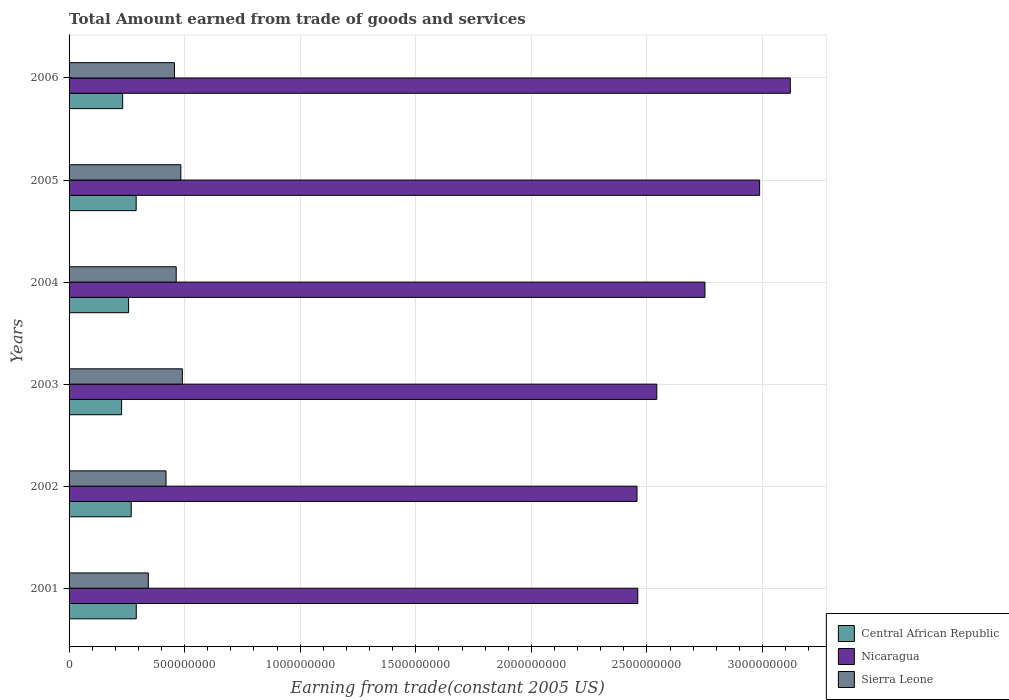Are the number of bars per tick equal to the number of legend labels?
Your response must be concise. Yes. Are the number of bars on each tick of the Y-axis equal?
Your answer should be very brief. Yes. How many bars are there on the 3rd tick from the bottom?
Offer a very short reply. 3. What is the label of the 1st group of bars from the top?
Your response must be concise. 2006. In how many cases, is the number of bars for a given year not equal to the number of legend labels?
Offer a terse response. 0. What is the total amount earned by trading goods and services in Nicaragua in 2003?
Ensure brevity in your answer.  2.54e+09. Across all years, what is the maximum total amount earned by trading goods and services in Nicaragua?
Keep it short and to the point. 3.12e+09. Across all years, what is the minimum total amount earned by trading goods and services in Sierra Leone?
Provide a succinct answer. 3.43e+08. What is the total total amount earned by trading goods and services in Central African Republic in the graph?
Offer a terse response. 1.57e+09. What is the difference between the total amount earned by trading goods and services in Central African Republic in 2001 and that in 2002?
Provide a succinct answer. 2.18e+07. What is the difference between the total amount earned by trading goods and services in Nicaragua in 2004 and the total amount earned by trading goods and services in Central African Republic in 2001?
Your response must be concise. 2.46e+09. What is the average total amount earned by trading goods and services in Central African Republic per year?
Your answer should be very brief. 2.61e+08. In the year 2006, what is the difference between the total amount earned by trading goods and services in Central African Republic and total amount earned by trading goods and services in Nicaragua?
Ensure brevity in your answer.  -2.89e+09. What is the ratio of the total amount earned by trading goods and services in Nicaragua in 2002 to that in 2003?
Offer a terse response. 0.97. Is the total amount earned by trading goods and services in Central African Republic in 2001 less than that in 2005?
Make the answer very short. No. What is the difference between the highest and the second highest total amount earned by trading goods and services in Nicaragua?
Offer a very short reply. 1.33e+08. What is the difference between the highest and the lowest total amount earned by trading goods and services in Sierra Leone?
Keep it short and to the point. 1.47e+08. Is the sum of the total amount earned by trading goods and services in Nicaragua in 2003 and 2004 greater than the maximum total amount earned by trading goods and services in Sierra Leone across all years?
Provide a succinct answer. Yes. What does the 1st bar from the top in 2003 represents?
Give a very brief answer. Sierra Leone. What does the 2nd bar from the bottom in 2005 represents?
Give a very brief answer. Nicaragua. Is it the case that in every year, the sum of the total amount earned by trading goods and services in Central African Republic and total amount earned by trading goods and services in Nicaragua is greater than the total amount earned by trading goods and services in Sierra Leone?
Ensure brevity in your answer.  Yes. How many bars are there?
Give a very brief answer. 18. Are all the bars in the graph horizontal?
Your answer should be very brief. Yes. Does the graph contain any zero values?
Your answer should be very brief. No. How many legend labels are there?
Provide a succinct answer. 3. How are the legend labels stacked?
Keep it short and to the point. Vertical. What is the title of the graph?
Provide a short and direct response. Total Amount earned from trade of goods and services. Does "Sub-Saharan Africa (developing only)" appear as one of the legend labels in the graph?
Offer a terse response. No. What is the label or title of the X-axis?
Give a very brief answer. Earning from trade(constant 2005 US). What is the label or title of the Y-axis?
Give a very brief answer. Years. What is the Earning from trade(constant 2005 US) in Central African Republic in 2001?
Keep it short and to the point. 2.91e+08. What is the Earning from trade(constant 2005 US) of Nicaragua in 2001?
Provide a succinct answer. 2.46e+09. What is the Earning from trade(constant 2005 US) of Sierra Leone in 2001?
Your answer should be very brief. 3.43e+08. What is the Earning from trade(constant 2005 US) in Central African Republic in 2002?
Provide a short and direct response. 2.69e+08. What is the Earning from trade(constant 2005 US) of Nicaragua in 2002?
Offer a terse response. 2.46e+09. What is the Earning from trade(constant 2005 US) in Sierra Leone in 2002?
Make the answer very short. 4.19e+08. What is the Earning from trade(constant 2005 US) in Central African Republic in 2003?
Provide a short and direct response. 2.27e+08. What is the Earning from trade(constant 2005 US) in Nicaragua in 2003?
Your answer should be compact. 2.54e+09. What is the Earning from trade(constant 2005 US) in Sierra Leone in 2003?
Ensure brevity in your answer.  4.90e+08. What is the Earning from trade(constant 2005 US) in Central African Republic in 2004?
Provide a short and direct response. 2.58e+08. What is the Earning from trade(constant 2005 US) in Nicaragua in 2004?
Offer a very short reply. 2.75e+09. What is the Earning from trade(constant 2005 US) in Sierra Leone in 2004?
Give a very brief answer. 4.63e+08. What is the Earning from trade(constant 2005 US) in Central African Republic in 2005?
Provide a succinct answer. 2.90e+08. What is the Earning from trade(constant 2005 US) in Nicaragua in 2005?
Provide a short and direct response. 2.99e+09. What is the Earning from trade(constant 2005 US) in Sierra Leone in 2005?
Your response must be concise. 4.84e+08. What is the Earning from trade(constant 2005 US) of Central African Republic in 2006?
Ensure brevity in your answer.  2.32e+08. What is the Earning from trade(constant 2005 US) of Nicaragua in 2006?
Keep it short and to the point. 3.12e+09. What is the Earning from trade(constant 2005 US) of Sierra Leone in 2006?
Your response must be concise. 4.56e+08. Across all years, what is the maximum Earning from trade(constant 2005 US) of Central African Republic?
Offer a very short reply. 2.91e+08. Across all years, what is the maximum Earning from trade(constant 2005 US) in Nicaragua?
Ensure brevity in your answer.  3.12e+09. Across all years, what is the maximum Earning from trade(constant 2005 US) in Sierra Leone?
Give a very brief answer. 4.90e+08. Across all years, what is the minimum Earning from trade(constant 2005 US) in Central African Republic?
Your answer should be very brief. 2.27e+08. Across all years, what is the minimum Earning from trade(constant 2005 US) of Nicaragua?
Offer a very short reply. 2.46e+09. Across all years, what is the minimum Earning from trade(constant 2005 US) of Sierra Leone?
Offer a very short reply. 3.43e+08. What is the total Earning from trade(constant 2005 US) of Central African Republic in the graph?
Make the answer very short. 1.57e+09. What is the total Earning from trade(constant 2005 US) in Nicaragua in the graph?
Your answer should be very brief. 1.63e+1. What is the total Earning from trade(constant 2005 US) of Sierra Leone in the graph?
Ensure brevity in your answer.  2.66e+09. What is the difference between the Earning from trade(constant 2005 US) of Central African Republic in 2001 and that in 2002?
Offer a very short reply. 2.18e+07. What is the difference between the Earning from trade(constant 2005 US) in Nicaragua in 2001 and that in 2002?
Your answer should be very brief. 3.38e+06. What is the difference between the Earning from trade(constant 2005 US) of Sierra Leone in 2001 and that in 2002?
Offer a very short reply. -7.66e+07. What is the difference between the Earning from trade(constant 2005 US) of Central African Republic in 2001 and that in 2003?
Provide a short and direct response. 6.35e+07. What is the difference between the Earning from trade(constant 2005 US) of Nicaragua in 2001 and that in 2003?
Offer a very short reply. -8.24e+07. What is the difference between the Earning from trade(constant 2005 US) of Sierra Leone in 2001 and that in 2003?
Provide a short and direct response. -1.47e+08. What is the difference between the Earning from trade(constant 2005 US) in Central African Republic in 2001 and that in 2004?
Your response must be concise. 3.32e+07. What is the difference between the Earning from trade(constant 2005 US) of Nicaragua in 2001 and that in 2004?
Keep it short and to the point. -2.91e+08. What is the difference between the Earning from trade(constant 2005 US) of Sierra Leone in 2001 and that in 2004?
Your answer should be very brief. -1.21e+08. What is the difference between the Earning from trade(constant 2005 US) in Central African Republic in 2001 and that in 2005?
Provide a short and direct response. 4.33e+05. What is the difference between the Earning from trade(constant 2005 US) of Nicaragua in 2001 and that in 2005?
Keep it short and to the point. -5.27e+08. What is the difference between the Earning from trade(constant 2005 US) of Sierra Leone in 2001 and that in 2005?
Provide a succinct answer. -1.41e+08. What is the difference between the Earning from trade(constant 2005 US) of Central African Republic in 2001 and that in 2006?
Offer a terse response. 5.88e+07. What is the difference between the Earning from trade(constant 2005 US) in Nicaragua in 2001 and that in 2006?
Make the answer very short. -6.60e+08. What is the difference between the Earning from trade(constant 2005 US) of Sierra Leone in 2001 and that in 2006?
Offer a very short reply. -1.13e+08. What is the difference between the Earning from trade(constant 2005 US) in Central African Republic in 2002 and that in 2003?
Keep it short and to the point. 4.16e+07. What is the difference between the Earning from trade(constant 2005 US) in Nicaragua in 2002 and that in 2003?
Provide a succinct answer. -8.57e+07. What is the difference between the Earning from trade(constant 2005 US) in Sierra Leone in 2002 and that in 2003?
Provide a short and direct response. -7.06e+07. What is the difference between the Earning from trade(constant 2005 US) in Central African Republic in 2002 and that in 2004?
Your answer should be very brief. 1.14e+07. What is the difference between the Earning from trade(constant 2005 US) of Nicaragua in 2002 and that in 2004?
Your answer should be very brief. -2.94e+08. What is the difference between the Earning from trade(constant 2005 US) in Sierra Leone in 2002 and that in 2004?
Make the answer very short. -4.41e+07. What is the difference between the Earning from trade(constant 2005 US) in Central African Republic in 2002 and that in 2005?
Keep it short and to the point. -2.14e+07. What is the difference between the Earning from trade(constant 2005 US) in Nicaragua in 2002 and that in 2005?
Make the answer very short. -5.31e+08. What is the difference between the Earning from trade(constant 2005 US) of Sierra Leone in 2002 and that in 2005?
Give a very brief answer. -6.42e+07. What is the difference between the Earning from trade(constant 2005 US) of Central African Republic in 2002 and that in 2006?
Offer a terse response. 3.69e+07. What is the difference between the Earning from trade(constant 2005 US) of Nicaragua in 2002 and that in 2006?
Your response must be concise. -6.63e+08. What is the difference between the Earning from trade(constant 2005 US) of Sierra Leone in 2002 and that in 2006?
Your answer should be compact. -3.66e+07. What is the difference between the Earning from trade(constant 2005 US) of Central African Republic in 2003 and that in 2004?
Your response must be concise. -3.02e+07. What is the difference between the Earning from trade(constant 2005 US) of Nicaragua in 2003 and that in 2004?
Your answer should be compact. -2.08e+08. What is the difference between the Earning from trade(constant 2005 US) in Sierra Leone in 2003 and that in 2004?
Your answer should be compact. 2.66e+07. What is the difference between the Earning from trade(constant 2005 US) in Central African Republic in 2003 and that in 2005?
Your answer should be very brief. -6.30e+07. What is the difference between the Earning from trade(constant 2005 US) of Nicaragua in 2003 and that in 2005?
Provide a succinct answer. -4.45e+08. What is the difference between the Earning from trade(constant 2005 US) of Sierra Leone in 2003 and that in 2005?
Offer a very short reply. 6.47e+06. What is the difference between the Earning from trade(constant 2005 US) in Central African Republic in 2003 and that in 2006?
Make the answer very short. -4.70e+06. What is the difference between the Earning from trade(constant 2005 US) in Nicaragua in 2003 and that in 2006?
Your answer should be very brief. -5.78e+08. What is the difference between the Earning from trade(constant 2005 US) of Sierra Leone in 2003 and that in 2006?
Offer a very short reply. 3.41e+07. What is the difference between the Earning from trade(constant 2005 US) in Central African Republic in 2004 and that in 2005?
Make the answer very short. -3.28e+07. What is the difference between the Earning from trade(constant 2005 US) of Nicaragua in 2004 and that in 2005?
Your answer should be very brief. -2.37e+08. What is the difference between the Earning from trade(constant 2005 US) in Sierra Leone in 2004 and that in 2005?
Provide a succinct answer. -2.01e+07. What is the difference between the Earning from trade(constant 2005 US) in Central African Republic in 2004 and that in 2006?
Keep it short and to the point. 2.55e+07. What is the difference between the Earning from trade(constant 2005 US) of Nicaragua in 2004 and that in 2006?
Offer a very short reply. -3.69e+08. What is the difference between the Earning from trade(constant 2005 US) of Sierra Leone in 2004 and that in 2006?
Provide a succinct answer. 7.48e+06. What is the difference between the Earning from trade(constant 2005 US) of Central African Republic in 2005 and that in 2006?
Ensure brevity in your answer.  5.83e+07. What is the difference between the Earning from trade(constant 2005 US) in Nicaragua in 2005 and that in 2006?
Offer a very short reply. -1.33e+08. What is the difference between the Earning from trade(constant 2005 US) of Sierra Leone in 2005 and that in 2006?
Give a very brief answer. 2.76e+07. What is the difference between the Earning from trade(constant 2005 US) in Central African Republic in 2001 and the Earning from trade(constant 2005 US) in Nicaragua in 2002?
Provide a short and direct response. -2.17e+09. What is the difference between the Earning from trade(constant 2005 US) of Central African Republic in 2001 and the Earning from trade(constant 2005 US) of Sierra Leone in 2002?
Provide a short and direct response. -1.29e+08. What is the difference between the Earning from trade(constant 2005 US) in Nicaragua in 2001 and the Earning from trade(constant 2005 US) in Sierra Leone in 2002?
Your answer should be very brief. 2.04e+09. What is the difference between the Earning from trade(constant 2005 US) in Central African Republic in 2001 and the Earning from trade(constant 2005 US) in Nicaragua in 2003?
Offer a terse response. -2.25e+09. What is the difference between the Earning from trade(constant 2005 US) of Central African Republic in 2001 and the Earning from trade(constant 2005 US) of Sierra Leone in 2003?
Ensure brevity in your answer.  -1.99e+08. What is the difference between the Earning from trade(constant 2005 US) of Nicaragua in 2001 and the Earning from trade(constant 2005 US) of Sierra Leone in 2003?
Ensure brevity in your answer.  1.97e+09. What is the difference between the Earning from trade(constant 2005 US) of Central African Republic in 2001 and the Earning from trade(constant 2005 US) of Nicaragua in 2004?
Make the answer very short. -2.46e+09. What is the difference between the Earning from trade(constant 2005 US) of Central African Republic in 2001 and the Earning from trade(constant 2005 US) of Sierra Leone in 2004?
Provide a short and direct response. -1.73e+08. What is the difference between the Earning from trade(constant 2005 US) in Nicaragua in 2001 and the Earning from trade(constant 2005 US) in Sierra Leone in 2004?
Your response must be concise. 2.00e+09. What is the difference between the Earning from trade(constant 2005 US) in Central African Republic in 2001 and the Earning from trade(constant 2005 US) in Nicaragua in 2005?
Ensure brevity in your answer.  -2.70e+09. What is the difference between the Earning from trade(constant 2005 US) in Central African Republic in 2001 and the Earning from trade(constant 2005 US) in Sierra Leone in 2005?
Provide a succinct answer. -1.93e+08. What is the difference between the Earning from trade(constant 2005 US) of Nicaragua in 2001 and the Earning from trade(constant 2005 US) of Sierra Leone in 2005?
Keep it short and to the point. 1.98e+09. What is the difference between the Earning from trade(constant 2005 US) in Central African Republic in 2001 and the Earning from trade(constant 2005 US) in Nicaragua in 2006?
Offer a terse response. -2.83e+09. What is the difference between the Earning from trade(constant 2005 US) in Central African Republic in 2001 and the Earning from trade(constant 2005 US) in Sierra Leone in 2006?
Provide a succinct answer. -1.65e+08. What is the difference between the Earning from trade(constant 2005 US) in Nicaragua in 2001 and the Earning from trade(constant 2005 US) in Sierra Leone in 2006?
Make the answer very short. 2.00e+09. What is the difference between the Earning from trade(constant 2005 US) in Central African Republic in 2002 and the Earning from trade(constant 2005 US) in Nicaragua in 2003?
Offer a terse response. -2.27e+09. What is the difference between the Earning from trade(constant 2005 US) of Central African Republic in 2002 and the Earning from trade(constant 2005 US) of Sierra Leone in 2003?
Your answer should be very brief. -2.21e+08. What is the difference between the Earning from trade(constant 2005 US) of Nicaragua in 2002 and the Earning from trade(constant 2005 US) of Sierra Leone in 2003?
Your answer should be very brief. 1.97e+09. What is the difference between the Earning from trade(constant 2005 US) of Central African Republic in 2002 and the Earning from trade(constant 2005 US) of Nicaragua in 2004?
Provide a succinct answer. -2.48e+09. What is the difference between the Earning from trade(constant 2005 US) in Central African Republic in 2002 and the Earning from trade(constant 2005 US) in Sierra Leone in 2004?
Provide a short and direct response. -1.95e+08. What is the difference between the Earning from trade(constant 2005 US) in Nicaragua in 2002 and the Earning from trade(constant 2005 US) in Sierra Leone in 2004?
Offer a very short reply. 1.99e+09. What is the difference between the Earning from trade(constant 2005 US) of Central African Republic in 2002 and the Earning from trade(constant 2005 US) of Nicaragua in 2005?
Keep it short and to the point. -2.72e+09. What is the difference between the Earning from trade(constant 2005 US) of Central African Republic in 2002 and the Earning from trade(constant 2005 US) of Sierra Leone in 2005?
Make the answer very short. -2.15e+08. What is the difference between the Earning from trade(constant 2005 US) of Nicaragua in 2002 and the Earning from trade(constant 2005 US) of Sierra Leone in 2005?
Make the answer very short. 1.97e+09. What is the difference between the Earning from trade(constant 2005 US) in Central African Republic in 2002 and the Earning from trade(constant 2005 US) in Nicaragua in 2006?
Your answer should be very brief. -2.85e+09. What is the difference between the Earning from trade(constant 2005 US) in Central African Republic in 2002 and the Earning from trade(constant 2005 US) in Sierra Leone in 2006?
Your answer should be compact. -1.87e+08. What is the difference between the Earning from trade(constant 2005 US) in Nicaragua in 2002 and the Earning from trade(constant 2005 US) in Sierra Leone in 2006?
Offer a very short reply. 2.00e+09. What is the difference between the Earning from trade(constant 2005 US) in Central African Republic in 2003 and the Earning from trade(constant 2005 US) in Nicaragua in 2004?
Provide a succinct answer. -2.52e+09. What is the difference between the Earning from trade(constant 2005 US) of Central African Republic in 2003 and the Earning from trade(constant 2005 US) of Sierra Leone in 2004?
Offer a terse response. -2.36e+08. What is the difference between the Earning from trade(constant 2005 US) of Nicaragua in 2003 and the Earning from trade(constant 2005 US) of Sierra Leone in 2004?
Your answer should be compact. 2.08e+09. What is the difference between the Earning from trade(constant 2005 US) in Central African Republic in 2003 and the Earning from trade(constant 2005 US) in Nicaragua in 2005?
Make the answer very short. -2.76e+09. What is the difference between the Earning from trade(constant 2005 US) of Central African Republic in 2003 and the Earning from trade(constant 2005 US) of Sierra Leone in 2005?
Give a very brief answer. -2.56e+08. What is the difference between the Earning from trade(constant 2005 US) of Nicaragua in 2003 and the Earning from trade(constant 2005 US) of Sierra Leone in 2005?
Provide a short and direct response. 2.06e+09. What is the difference between the Earning from trade(constant 2005 US) in Central African Republic in 2003 and the Earning from trade(constant 2005 US) in Nicaragua in 2006?
Provide a short and direct response. -2.89e+09. What is the difference between the Earning from trade(constant 2005 US) in Central African Republic in 2003 and the Earning from trade(constant 2005 US) in Sierra Leone in 2006?
Keep it short and to the point. -2.29e+08. What is the difference between the Earning from trade(constant 2005 US) of Nicaragua in 2003 and the Earning from trade(constant 2005 US) of Sierra Leone in 2006?
Keep it short and to the point. 2.09e+09. What is the difference between the Earning from trade(constant 2005 US) in Central African Republic in 2004 and the Earning from trade(constant 2005 US) in Nicaragua in 2005?
Your answer should be very brief. -2.73e+09. What is the difference between the Earning from trade(constant 2005 US) in Central African Republic in 2004 and the Earning from trade(constant 2005 US) in Sierra Leone in 2005?
Ensure brevity in your answer.  -2.26e+08. What is the difference between the Earning from trade(constant 2005 US) of Nicaragua in 2004 and the Earning from trade(constant 2005 US) of Sierra Leone in 2005?
Offer a very short reply. 2.27e+09. What is the difference between the Earning from trade(constant 2005 US) in Central African Republic in 2004 and the Earning from trade(constant 2005 US) in Nicaragua in 2006?
Offer a very short reply. -2.86e+09. What is the difference between the Earning from trade(constant 2005 US) in Central African Republic in 2004 and the Earning from trade(constant 2005 US) in Sierra Leone in 2006?
Provide a short and direct response. -1.98e+08. What is the difference between the Earning from trade(constant 2005 US) in Nicaragua in 2004 and the Earning from trade(constant 2005 US) in Sierra Leone in 2006?
Your answer should be very brief. 2.30e+09. What is the difference between the Earning from trade(constant 2005 US) in Central African Republic in 2005 and the Earning from trade(constant 2005 US) in Nicaragua in 2006?
Provide a short and direct response. -2.83e+09. What is the difference between the Earning from trade(constant 2005 US) in Central African Republic in 2005 and the Earning from trade(constant 2005 US) in Sierra Leone in 2006?
Make the answer very short. -1.66e+08. What is the difference between the Earning from trade(constant 2005 US) in Nicaragua in 2005 and the Earning from trade(constant 2005 US) in Sierra Leone in 2006?
Keep it short and to the point. 2.53e+09. What is the average Earning from trade(constant 2005 US) in Central African Republic per year?
Your answer should be compact. 2.61e+08. What is the average Earning from trade(constant 2005 US) in Nicaragua per year?
Keep it short and to the point. 2.72e+09. What is the average Earning from trade(constant 2005 US) of Sierra Leone per year?
Make the answer very short. 4.43e+08. In the year 2001, what is the difference between the Earning from trade(constant 2005 US) of Central African Republic and Earning from trade(constant 2005 US) of Nicaragua?
Keep it short and to the point. -2.17e+09. In the year 2001, what is the difference between the Earning from trade(constant 2005 US) in Central African Republic and Earning from trade(constant 2005 US) in Sierra Leone?
Ensure brevity in your answer.  -5.21e+07. In the year 2001, what is the difference between the Earning from trade(constant 2005 US) in Nicaragua and Earning from trade(constant 2005 US) in Sierra Leone?
Make the answer very short. 2.12e+09. In the year 2002, what is the difference between the Earning from trade(constant 2005 US) of Central African Republic and Earning from trade(constant 2005 US) of Nicaragua?
Keep it short and to the point. -2.19e+09. In the year 2002, what is the difference between the Earning from trade(constant 2005 US) of Central African Republic and Earning from trade(constant 2005 US) of Sierra Leone?
Your response must be concise. -1.51e+08. In the year 2002, what is the difference between the Earning from trade(constant 2005 US) of Nicaragua and Earning from trade(constant 2005 US) of Sierra Leone?
Ensure brevity in your answer.  2.04e+09. In the year 2003, what is the difference between the Earning from trade(constant 2005 US) of Central African Republic and Earning from trade(constant 2005 US) of Nicaragua?
Offer a terse response. -2.32e+09. In the year 2003, what is the difference between the Earning from trade(constant 2005 US) of Central African Republic and Earning from trade(constant 2005 US) of Sierra Leone?
Ensure brevity in your answer.  -2.63e+08. In the year 2003, what is the difference between the Earning from trade(constant 2005 US) in Nicaragua and Earning from trade(constant 2005 US) in Sierra Leone?
Ensure brevity in your answer.  2.05e+09. In the year 2004, what is the difference between the Earning from trade(constant 2005 US) in Central African Republic and Earning from trade(constant 2005 US) in Nicaragua?
Make the answer very short. -2.49e+09. In the year 2004, what is the difference between the Earning from trade(constant 2005 US) in Central African Republic and Earning from trade(constant 2005 US) in Sierra Leone?
Ensure brevity in your answer.  -2.06e+08. In the year 2004, what is the difference between the Earning from trade(constant 2005 US) of Nicaragua and Earning from trade(constant 2005 US) of Sierra Leone?
Make the answer very short. 2.29e+09. In the year 2005, what is the difference between the Earning from trade(constant 2005 US) of Central African Republic and Earning from trade(constant 2005 US) of Nicaragua?
Offer a terse response. -2.70e+09. In the year 2005, what is the difference between the Earning from trade(constant 2005 US) in Central African Republic and Earning from trade(constant 2005 US) in Sierra Leone?
Give a very brief answer. -1.93e+08. In the year 2005, what is the difference between the Earning from trade(constant 2005 US) in Nicaragua and Earning from trade(constant 2005 US) in Sierra Leone?
Keep it short and to the point. 2.50e+09. In the year 2006, what is the difference between the Earning from trade(constant 2005 US) in Central African Republic and Earning from trade(constant 2005 US) in Nicaragua?
Provide a succinct answer. -2.89e+09. In the year 2006, what is the difference between the Earning from trade(constant 2005 US) in Central African Republic and Earning from trade(constant 2005 US) in Sierra Leone?
Keep it short and to the point. -2.24e+08. In the year 2006, what is the difference between the Earning from trade(constant 2005 US) in Nicaragua and Earning from trade(constant 2005 US) in Sierra Leone?
Provide a short and direct response. 2.66e+09. What is the ratio of the Earning from trade(constant 2005 US) of Central African Republic in 2001 to that in 2002?
Offer a terse response. 1.08. What is the ratio of the Earning from trade(constant 2005 US) in Sierra Leone in 2001 to that in 2002?
Ensure brevity in your answer.  0.82. What is the ratio of the Earning from trade(constant 2005 US) of Central African Republic in 2001 to that in 2003?
Your answer should be very brief. 1.28. What is the ratio of the Earning from trade(constant 2005 US) in Nicaragua in 2001 to that in 2003?
Offer a very short reply. 0.97. What is the ratio of the Earning from trade(constant 2005 US) of Sierra Leone in 2001 to that in 2003?
Keep it short and to the point. 0.7. What is the ratio of the Earning from trade(constant 2005 US) in Central African Republic in 2001 to that in 2004?
Ensure brevity in your answer.  1.13. What is the ratio of the Earning from trade(constant 2005 US) of Nicaragua in 2001 to that in 2004?
Provide a short and direct response. 0.89. What is the ratio of the Earning from trade(constant 2005 US) in Sierra Leone in 2001 to that in 2004?
Provide a succinct answer. 0.74. What is the ratio of the Earning from trade(constant 2005 US) of Nicaragua in 2001 to that in 2005?
Provide a short and direct response. 0.82. What is the ratio of the Earning from trade(constant 2005 US) of Sierra Leone in 2001 to that in 2005?
Your answer should be compact. 0.71. What is the ratio of the Earning from trade(constant 2005 US) in Central African Republic in 2001 to that in 2006?
Ensure brevity in your answer.  1.25. What is the ratio of the Earning from trade(constant 2005 US) of Nicaragua in 2001 to that in 2006?
Offer a very short reply. 0.79. What is the ratio of the Earning from trade(constant 2005 US) of Sierra Leone in 2001 to that in 2006?
Offer a terse response. 0.75. What is the ratio of the Earning from trade(constant 2005 US) in Central African Republic in 2002 to that in 2003?
Your answer should be very brief. 1.18. What is the ratio of the Earning from trade(constant 2005 US) in Nicaragua in 2002 to that in 2003?
Ensure brevity in your answer.  0.97. What is the ratio of the Earning from trade(constant 2005 US) in Sierra Leone in 2002 to that in 2003?
Your answer should be very brief. 0.86. What is the ratio of the Earning from trade(constant 2005 US) of Central African Republic in 2002 to that in 2004?
Your answer should be compact. 1.04. What is the ratio of the Earning from trade(constant 2005 US) in Nicaragua in 2002 to that in 2004?
Offer a terse response. 0.89. What is the ratio of the Earning from trade(constant 2005 US) of Sierra Leone in 2002 to that in 2004?
Your answer should be compact. 0.91. What is the ratio of the Earning from trade(constant 2005 US) in Central African Republic in 2002 to that in 2005?
Make the answer very short. 0.93. What is the ratio of the Earning from trade(constant 2005 US) in Nicaragua in 2002 to that in 2005?
Offer a very short reply. 0.82. What is the ratio of the Earning from trade(constant 2005 US) of Sierra Leone in 2002 to that in 2005?
Your response must be concise. 0.87. What is the ratio of the Earning from trade(constant 2005 US) of Central African Republic in 2002 to that in 2006?
Make the answer very short. 1.16. What is the ratio of the Earning from trade(constant 2005 US) in Nicaragua in 2002 to that in 2006?
Keep it short and to the point. 0.79. What is the ratio of the Earning from trade(constant 2005 US) in Sierra Leone in 2002 to that in 2006?
Give a very brief answer. 0.92. What is the ratio of the Earning from trade(constant 2005 US) of Central African Republic in 2003 to that in 2004?
Your response must be concise. 0.88. What is the ratio of the Earning from trade(constant 2005 US) of Nicaragua in 2003 to that in 2004?
Ensure brevity in your answer.  0.92. What is the ratio of the Earning from trade(constant 2005 US) in Sierra Leone in 2003 to that in 2004?
Make the answer very short. 1.06. What is the ratio of the Earning from trade(constant 2005 US) in Central African Republic in 2003 to that in 2005?
Give a very brief answer. 0.78. What is the ratio of the Earning from trade(constant 2005 US) in Nicaragua in 2003 to that in 2005?
Offer a very short reply. 0.85. What is the ratio of the Earning from trade(constant 2005 US) in Sierra Leone in 2003 to that in 2005?
Offer a terse response. 1.01. What is the ratio of the Earning from trade(constant 2005 US) in Central African Republic in 2003 to that in 2006?
Your response must be concise. 0.98. What is the ratio of the Earning from trade(constant 2005 US) of Nicaragua in 2003 to that in 2006?
Keep it short and to the point. 0.81. What is the ratio of the Earning from trade(constant 2005 US) in Sierra Leone in 2003 to that in 2006?
Offer a very short reply. 1.07. What is the ratio of the Earning from trade(constant 2005 US) of Central African Republic in 2004 to that in 2005?
Offer a very short reply. 0.89. What is the ratio of the Earning from trade(constant 2005 US) in Nicaragua in 2004 to that in 2005?
Offer a terse response. 0.92. What is the ratio of the Earning from trade(constant 2005 US) in Sierra Leone in 2004 to that in 2005?
Your answer should be compact. 0.96. What is the ratio of the Earning from trade(constant 2005 US) in Central African Republic in 2004 to that in 2006?
Ensure brevity in your answer.  1.11. What is the ratio of the Earning from trade(constant 2005 US) of Nicaragua in 2004 to that in 2006?
Keep it short and to the point. 0.88. What is the ratio of the Earning from trade(constant 2005 US) in Sierra Leone in 2004 to that in 2006?
Provide a succinct answer. 1.02. What is the ratio of the Earning from trade(constant 2005 US) in Central African Republic in 2005 to that in 2006?
Make the answer very short. 1.25. What is the ratio of the Earning from trade(constant 2005 US) in Nicaragua in 2005 to that in 2006?
Ensure brevity in your answer.  0.96. What is the ratio of the Earning from trade(constant 2005 US) in Sierra Leone in 2005 to that in 2006?
Offer a terse response. 1.06. What is the difference between the highest and the second highest Earning from trade(constant 2005 US) of Central African Republic?
Offer a terse response. 4.33e+05. What is the difference between the highest and the second highest Earning from trade(constant 2005 US) of Nicaragua?
Provide a succinct answer. 1.33e+08. What is the difference between the highest and the second highest Earning from trade(constant 2005 US) in Sierra Leone?
Make the answer very short. 6.47e+06. What is the difference between the highest and the lowest Earning from trade(constant 2005 US) of Central African Republic?
Offer a very short reply. 6.35e+07. What is the difference between the highest and the lowest Earning from trade(constant 2005 US) of Nicaragua?
Offer a terse response. 6.63e+08. What is the difference between the highest and the lowest Earning from trade(constant 2005 US) of Sierra Leone?
Ensure brevity in your answer.  1.47e+08. 